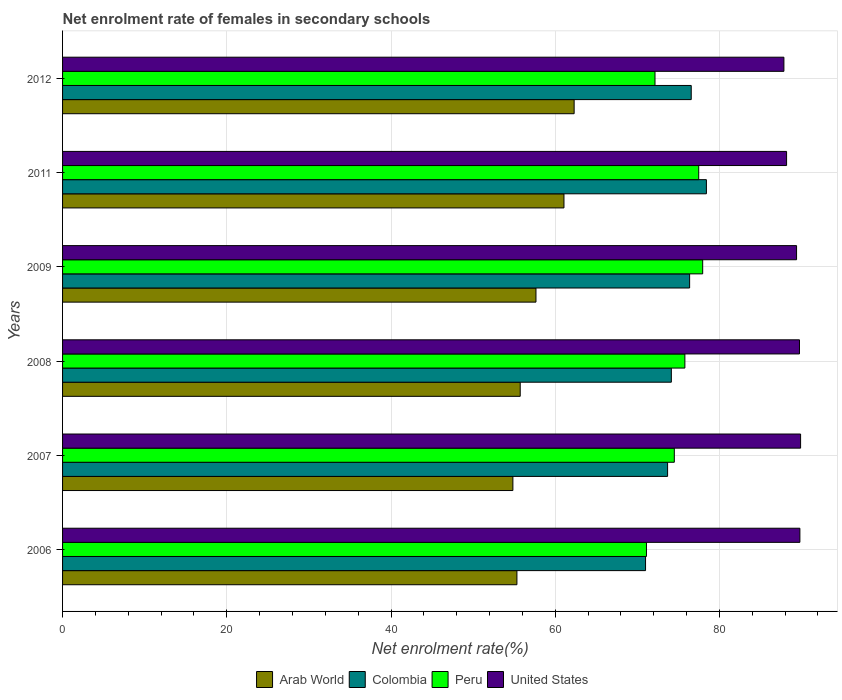How many different coloured bars are there?
Your answer should be very brief. 4. How many bars are there on the 5th tick from the bottom?
Make the answer very short. 4. What is the net enrolment rate of females in secondary schools in United States in 2007?
Make the answer very short. 89.88. Across all years, what is the maximum net enrolment rate of females in secondary schools in Arab World?
Ensure brevity in your answer.  62.3. Across all years, what is the minimum net enrolment rate of females in secondary schools in United States?
Offer a terse response. 87.85. In which year was the net enrolment rate of females in secondary schools in Peru maximum?
Ensure brevity in your answer.  2009. What is the total net enrolment rate of females in secondary schools in Arab World in the graph?
Your answer should be very brief. 346.93. What is the difference between the net enrolment rate of females in secondary schools in Peru in 2007 and that in 2009?
Provide a succinct answer. -3.45. What is the difference between the net enrolment rate of females in secondary schools in Colombia in 2009 and the net enrolment rate of females in secondary schools in Peru in 2011?
Offer a terse response. -1.11. What is the average net enrolment rate of females in secondary schools in Arab World per year?
Ensure brevity in your answer.  57.82. In the year 2008, what is the difference between the net enrolment rate of females in secondary schools in Peru and net enrolment rate of females in secondary schools in Colombia?
Keep it short and to the point. 1.65. What is the ratio of the net enrolment rate of females in secondary schools in United States in 2006 to that in 2008?
Your answer should be compact. 1. Is the difference between the net enrolment rate of females in secondary schools in Peru in 2009 and 2012 greater than the difference between the net enrolment rate of females in secondary schools in Colombia in 2009 and 2012?
Offer a very short reply. Yes. What is the difference between the highest and the second highest net enrolment rate of females in secondary schools in United States?
Provide a succinct answer. 0.08. What is the difference between the highest and the lowest net enrolment rate of females in secondary schools in Peru?
Provide a short and direct response. 6.85. In how many years, is the net enrolment rate of females in secondary schools in Colombia greater than the average net enrolment rate of females in secondary schools in Colombia taken over all years?
Offer a very short reply. 3. Is it the case that in every year, the sum of the net enrolment rate of females in secondary schools in Arab World and net enrolment rate of females in secondary schools in United States is greater than the sum of net enrolment rate of females in secondary schools in Colombia and net enrolment rate of females in secondary schools in Peru?
Provide a succinct answer. No. What does the 1st bar from the bottom in 2009 represents?
Your response must be concise. Arab World. Does the graph contain any zero values?
Offer a terse response. No. How many legend labels are there?
Your response must be concise. 4. What is the title of the graph?
Make the answer very short. Net enrolment rate of females in secondary schools. Does "Benin" appear as one of the legend labels in the graph?
Your response must be concise. No. What is the label or title of the X-axis?
Your response must be concise. Net enrolment rate(%). What is the label or title of the Y-axis?
Your answer should be very brief. Years. What is the Net enrolment rate(%) of Arab World in 2006?
Provide a succinct answer. 55.33. What is the Net enrolment rate(%) of Colombia in 2006?
Keep it short and to the point. 71. What is the Net enrolment rate(%) in Peru in 2006?
Provide a succinct answer. 71.11. What is the Net enrolment rate(%) in United States in 2006?
Ensure brevity in your answer.  89.8. What is the Net enrolment rate(%) of Arab World in 2007?
Keep it short and to the point. 54.84. What is the Net enrolment rate(%) in Colombia in 2007?
Your answer should be very brief. 73.68. What is the Net enrolment rate(%) in Peru in 2007?
Your answer should be compact. 74.5. What is the Net enrolment rate(%) in United States in 2007?
Offer a very short reply. 89.88. What is the Net enrolment rate(%) of Arab World in 2008?
Your answer should be very brief. 55.74. What is the Net enrolment rate(%) in Colombia in 2008?
Keep it short and to the point. 74.14. What is the Net enrolment rate(%) of Peru in 2008?
Your answer should be very brief. 75.79. What is the Net enrolment rate(%) in United States in 2008?
Give a very brief answer. 89.75. What is the Net enrolment rate(%) of Arab World in 2009?
Keep it short and to the point. 57.65. What is the Net enrolment rate(%) in Colombia in 2009?
Provide a short and direct response. 76.37. What is the Net enrolment rate(%) of Peru in 2009?
Your response must be concise. 77.96. What is the Net enrolment rate(%) of United States in 2009?
Give a very brief answer. 89.39. What is the Net enrolment rate(%) of Arab World in 2011?
Offer a terse response. 61.06. What is the Net enrolment rate(%) in Colombia in 2011?
Keep it short and to the point. 78.41. What is the Net enrolment rate(%) in Peru in 2011?
Provide a short and direct response. 77.47. What is the Net enrolment rate(%) of United States in 2011?
Offer a terse response. 88.17. What is the Net enrolment rate(%) in Arab World in 2012?
Provide a succinct answer. 62.3. What is the Net enrolment rate(%) in Colombia in 2012?
Provide a short and direct response. 76.56. What is the Net enrolment rate(%) of Peru in 2012?
Give a very brief answer. 72.15. What is the Net enrolment rate(%) of United States in 2012?
Offer a terse response. 87.85. Across all years, what is the maximum Net enrolment rate(%) of Arab World?
Keep it short and to the point. 62.3. Across all years, what is the maximum Net enrolment rate(%) in Colombia?
Provide a short and direct response. 78.41. Across all years, what is the maximum Net enrolment rate(%) of Peru?
Keep it short and to the point. 77.96. Across all years, what is the maximum Net enrolment rate(%) of United States?
Make the answer very short. 89.88. Across all years, what is the minimum Net enrolment rate(%) of Arab World?
Make the answer very short. 54.84. Across all years, what is the minimum Net enrolment rate(%) in Colombia?
Make the answer very short. 71. Across all years, what is the minimum Net enrolment rate(%) in Peru?
Ensure brevity in your answer.  71.11. Across all years, what is the minimum Net enrolment rate(%) in United States?
Keep it short and to the point. 87.85. What is the total Net enrolment rate(%) of Arab World in the graph?
Offer a terse response. 346.93. What is the total Net enrolment rate(%) of Colombia in the graph?
Ensure brevity in your answer.  450.16. What is the total Net enrolment rate(%) of Peru in the graph?
Give a very brief answer. 448.99. What is the total Net enrolment rate(%) in United States in the graph?
Offer a terse response. 534.84. What is the difference between the Net enrolment rate(%) of Arab World in 2006 and that in 2007?
Your answer should be very brief. 0.49. What is the difference between the Net enrolment rate(%) of Colombia in 2006 and that in 2007?
Offer a terse response. -2.68. What is the difference between the Net enrolment rate(%) of Peru in 2006 and that in 2007?
Offer a terse response. -3.39. What is the difference between the Net enrolment rate(%) of United States in 2006 and that in 2007?
Your answer should be compact. -0.08. What is the difference between the Net enrolment rate(%) of Arab World in 2006 and that in 2008?
Your answer should be compact. -0.4. What is the difference between the Net enrolment rate(%) of Colombia in 2006 and that in 2008?
Offer a very short reply. -3.14. What is the difference between the Net enrolment rate(%) in Peru in 2006 and that in 2008?
Your answer should be very brief. -4.68. What is the difference between the Net enrolment rate(%) in United States in 2006 and that in 2008?
Make the answer very short. 0.05. What is the difference between the Net enrolment rate(%) of Arab World in 2006 and that in 2009?
Your response must be concise. -2.32. What is the difference between the Net enrolment rate(%) in Colombia in 2006 and that in 2009?
Your response must be concise. -5.37. What is the difference between the Net enrolment rate(%) in Peru in 2006 and that in 2009?
Your answer should be very brief. -6.85. What is the difference between the Net enrolment rate(%) of United States in 2006 and that in 2009?
Keep it short and to the point. 0.41. What is the difference between the Net enrolment rate(%) of Arab World in 2006 and that in 2011?
Your answer should be very brief. -5.73. What is the difference between the Net enrolment rate(%) of Colombia in 2006 and that in 2011?
Ensure brevity in your answer.  -7.41. What is the difference between the Net enrolment rate(%) of Peru in 2006 and that in 2011?
Offer a very short reply. -6.36. What is the difference between the Net enrolment rate(%) of United States in 2006 and that in 2011?
Your answer should be compact. 1.62. What is the difference between the Net enrolment rate(%) of Arab World in 2006 and that in 2012?
Offer a very short reply. -6.97. What is the difference between the Net enrolment rate(%) in Colombia in 2006 and that in 2012?
Keep it short and to the point. -5.56. What is the difference between the Net enrolment rate(%) of Peru in 2006 and that in 2012?
Give a very brief answer. -1.04. What is the difference between the Net enrolment rate(%) in United States in 2006 and that in 2012?
Your response must be concise. 1.95. What is the difference between the Net enrolment rate(%) in Arab World in 2007 and that in 2008?
Ensure brevity in your answer.  -0.89. What is the difference between the Net enrolment rate(%) in Colombia in 2007 and that in 2008?
Your answer should be very brief. -0.46. What is the difference between the Net enrolment rate(%) in Peru in 2007 and that in 2008?
Your answer should be very brief. -1.29. What is the difference between the Net enrolment rate(%) of United States in 2007 and that in 2008?
Keep it short and to the point. 0.13. What is the difference between the Net enrolment rate(%) in Arab World in 2007 and that in 2009?
Offer a very short reply. -2.81. What is the difference between the Net enrolment rate(%) in Colombia in 2007 and that in 2009?
Ensure brevity in your answer.  -2.68. What is the difference between the Net enrolment rate(%) in Peru in 2007 and that in 2009?
Offer a terse response. -3.45. What is the difference between the Net enrolment rate(%) of United States in 2007 and that in 2009?
Make the answer very short. 0.49. What is the difference between the Net enrolment rate(%) in Arab World in 2007 and that in 2011?
Make the answer very short. -6.22. What is the difference between the Net enrolment rate(%) of Colombia in 2007 and that in 2011?
Your answer should be compact. -4.73. What is the difference between the Net enrolment rate(%) of Peru in 2007 and that in 2011?
Offer a very short reply. -2.97. What is the difference between the Net enrolment rate(%) of United States in 2007 and that in 2011?
Your answer should be compact. 1.71. What is the difference between the Net enrolment rate(%) in Arab World in 2007 and that in 2012?
Make the answer very short. -7.46. What is the difference between the Net enrolment rate(%) in Colombia in 2007 and that in 2012?
Offer a very short reply. -2.88. What is the difference between the Net enrolment rate(%) of Peru in 2007 and that in 2012?
Your answer should be very brief. 2.35. What is the difference between the Net enrolment rate(%) in United States in 2007 and that in 2012?
Your answer should be compact. 2.03. What is the difference between the Net enrolment rate(%) of Arab World in 2008 and that in 2009?
Give a very brief answer. -1.92. What is the difference between the Net enrolment rate(%) in Colombia in 2008 and that in 2009?
Provide a succinct answer. -2.23. What is the difference between the Net enrolment rate(%) of Peru in 2008 and that in 2009?
Provide a succinct answer. -2.17. What is the difference between the Net enrolment rate(%) in United States in 2008 and that in 2009?
Provide a succinct answer. 0.36. What is the difference between the Net enrolment rate(%) of Arab World in 2008 and that in 2011?
Provide a succinct answer. -5.33. What is the difference between the Net enrolment rate(%) in Colombia in 2008 and that in 2011?
Provide a succinct answer. -4.27. What is the difference between the Net enrolment rate(%) in Peru in 2008 and that in 2011?
Your answer should be very brief. -1.69. What is the difference between the Net enrolment rate(%) in United States in 2008 and that in 2011?
Offer a terse response. 1.57. What is the difference between the Net enrolment rate(%) in Arab World in 2008 and that in 2012?
Your answer should be very brief. -6.57. What is the difference between the Net enrolment rate(%) of Colombia in 2008 and that in 2012?
Your answer should be very brief. -2.42. What is the difference between the Net enrolment rate(%) of Peru in 2008 and that in 2012?
Your answer should be compact. 3.64. What is the difference between the Net enrolment rate(%) of United States in 2008 and that in 2012?
Ensure brevity in your answer.  1.9. What is the difference between the Net enrolment rate(%) of Arab World in 2009 and that in 2011?
Provide a succinct answer. -3.41. What is the difference between the Net enrolment rate(%) in Colombia in 2009 and that in 2011?
Offer a very short reply. -2.04. What is the difference between the Net enrolment rate(%) in Peru in 2009 and that in 2011?
Provide a short and direct response. 0.48. What is the difference between the Net enrolment rate(%) in United States in 2009 and that in 2011?
Provide a succinct answer. 1.22. What is the difference between the Net enrolment rate(%) in Arab World in 2009 and that in 2012?
Offer a very short reply. -4.65. What is the difference between the Net enrolment rate(%) of Colombia in 2009 and that in 2012?
Ensure brevity in your answer.  -0.19. What is the difference between the Net enrolment rate(%) of Peru in 2009 and that in 2012?
Make the answer very short. 5.81. What is the difference between the Net enrolment rate(%) in United States in 2009 and that in 2012?
Offer a terse response. 1.54. What is the difference between the Net enrolment rate(%) of Arab World in 2011 and that in 2012?
Provide a succinct answer. -1.24. What is the difference between the Net enrolment rate(%) in Colombia in 2011 and that in 2012?
Ensure brevity in your answer.  1.85. What is the difference between the Net enrolment rate(%) of Peru in 2011 and that in 2012?
Keep it short and to the point. 5.32. What is the difference between the Net enrolment rate(%) in United States in 2011 and that in 2012?
Offer a terse response. 0.33. What is the difference between the Net enrolment rate(%) of Arab World in 2006 and the Net enrolment rate(%) of Colombia in 2007?
Keep it short and to the point. -18.35. What is the difference between the Net enrolment rate(%) in Arab World in 2006 and the Net enrolment rate(%) in Peru in 2007?
Offer a very short reply. -19.17. What is the difference between the Net enrolment rate(%) of Arab World in 2006 and the Net enrolment rate(%) of United States in 2007?
Your response must be concise. -34.55. What is the difference between the Net enrolment rate(%) of Colombia in 2006 and the Net enrolment rate(%) of Peru in 2007?
Offer a very short reply. -3.5. What is the difference between the Net enrolment rate(%) in Colombia in 2006 and the Net enrolment rate(%) in United States in 2007?
Make the answer very short. -18.88. What is the difference between the Net enrolment rate(%) of Peru in 2006 and the Net enrolment rate(%) of United States in 2007?
Make the answer very short. -18.77. What is the difference between the Net enrolment rate(%) of Arab World in 2006 and the Net enrolment rate(%) of Colombia in 2008?
Make the answer very short. -18.81. What is the difference between the Net enrolment rate(%) of Arab World in 2006 and the Net enrolment rate(%) of Peru in 2008?
Your response must be concise. -20.45. What is the difference between the Net enrolment rate(%) in Arab World in 2006 and the Net enrolment rate(%) in United States in 2008?
Make the answer very short. -34.41. What is the difference between the Net enrolment rate(%) of Colombia in 2006 and the Net enrolment rate(%) of Peru in 2008?
Offer a very short reply. -4.79. What is the difference between the Net enrolment rate(%) in Colombia in 2006 and the Net enrolment rate(%) in United States in 2008?
Keep it short and to the point. -18.75. What is the difference between the Net enrolment rate(%) in Peru in 2006 and the Net enrolment rate(%) in United States in 2008?
Make the answer very short. -18.64. What is the difference between the Net enrolment rate(%) in Arab World in 2006 and the Net enrolment rate(%) in Colombia in 2009?
Offer a terse response. -21.03. What is the difference between the Net enrolment rate(%) in Arab World in 2006 and the Net enrolment rate(%) in Peru in 2009?
Your response must be concise. -22.62. What is the difference between the Net enrolment rate(%) in Arab World in 2006 and the Net enrolment rate(%) in United States in 2009?
Offer a very short reply. -34.06. What is the difference between the Net enrolment rate(%) in Colombia in 2006 and the Net enrolment rate(%) in Peru in 2009?
Provide a short and direct response. -6.96. What is the difference between the Net enrolment rate(%) in Colombia in 2006 and the Net enrolment rate(%) in United States in 2009?
Ensure brevity in your answer.  -18.39. What is the difference between the Net enrolment rate(%) in Peru in 2006 and the Net enrolment rate(%) in United States in 2009?
Ensure brevity in your answer.  -18.28. What is the difference between the Net enrolment rate(%) in Arab World in 2006 and the Net enrolment rate(%) in Colombia in 2011?
Provide a short and direct response. -23.08. What is the difference between the Net enrolment rate(%) of Arab World in 2006 and the Net enrolment rate(%) of Peru in 2011?
Ensure brevity in your answer.  -22.14. What is the difference between the Net enrolment rate(%) of Arab World in 2006 and the Net enrolment rate(%) of United States in 2011?
Offer a very short reply. -32.84. What is the difference between the Net enrolment rate(%) in Colombia in 2006 and the Net enrolment rate(%) in Peru in 2011?
Provide a succinct answer. -6.48. What is the difference between the Net enrolment rate(%) of Colombia in 2006 and the Net enrolment rate(%) of United States in 2011?
Provide a succinct answer. -17.18. What is the difference between the Net enrolment rate(%) of Peru in 2006 and the Net enrolment rate(%) of United States in 2011?
Keep it short and to the point. -17.06. What is the difference between the Net enrolment rate(%) in Arab World in 2006 and the Net enrolment rate(%) in Colombia in 2012?
Provide a short and direct response. -21.23. What is the difference between the Net enrolment rate(%) in Arab World in 2006 and the Net enrolment rate(%) in Peru in 2012?
Your answer should be very brief. -16.82. What is the difference between the Net enrolment rate(%) in Arab World in 2006 and the Net enrolment rate(%) in United States in 2012?
Ensure brevity in your answer.  -32.52. What is the difference between the Net enrolment rate(%) of Colombia in 2006 and the Net enrolment rate(%) of Peru in 2012?
Your answer should be compact. -1.15. What is the difference between the Net enrolment rate(%) in Colombia in 2006 and the Net enrolment rate(%) in United States in 2012?
Keep it short and to the point. -16.85. What is the difference between the Net enrolment rate(%) in Peru in 2006 and the Net enrolment rate(%) in United States in 2012?
Provide a succinct answer. -16.74. What is the difference between the Net enrolment rate(%) of Arab World in 2007 and the Net enrolment rate(%) of Colombia in 2008?
Give a very brief answer. -19.3. What is the difference between the Net enrolment rate(%) in Arab World in 2007 and the Net enrolment rate(%) in Peru in 2008?
Provide a succinct answer. -20.94. What is the difference between the Net enrolment rate(%) in Arab World in 2007 and the Net enrolment rate(%) in United States in 2008?
Your answer should be very brief. -34.9. What is the difference between the Net enrolment rate(%) in Colombia in 2007 and the Net enrolment rate(%) in Peru in 2008?
Your answer should be very brief. -2.11. What is the difference between the Net enrolment rate(%) of Colombia in 2007 and the Net enrolment rate(%) of United States in 2008?
Offer a terse response. -16.06. What is the difference between the Net enrolment rate(%) in Peru in 2007 and the Net enrolment rate(%) in United States in 2008?
Provide a short and direct response. -15.24. What is the difference between the Net enrolment rate(%) in Arab World in 2007 and the Net enrolment rate(%) in Colombia in 2009?
Provide a short and direct response. -21.52. What is the difference between the Net enrolment rate(%) of Arab World in 2007 and the Net enrolment rate(%) of Peru in 2009?
Ensure brevity in your answer.  -23.11. What is the difference between the Net enrolment rate(%) in Arab World in 2007 and the Net enrolment rate(%) in United States in 2009?
Your response must be concise. -34.55. What is the difference between the Net enrolment rate(%) of Colombia in 2007 and the Net enrolment rate(%) of Peru in 2009?
Your response must be concise. -4.27. What is the difference between the Net enrolment rate(%) of Colombia in 2007 and the Net enrolment rate(%) of United States in 2009?
Your response must be concise. -15.71. What is the difference between the Net enrolment rate(%) in Peru in 2007 and the Net enrolment rate(%) in United States in 2009?
Make the answer very short. -14.89. What is the difference between the Net enrolment rate(%) of Arab World in 2007 and the Net enrolment rate(%) of Colombia in 2011?
Give a very brief answer. -23.57. What is the difference between the Net enrolment rate(%) in Arab World in 2007 and the Net enrolment rate(%) in Peru in 2011?
Offer a terse response. -22.63. What is the difference between the Net enrolment rate(%) in Arab World in 2007 and the Net enrolment rate(%) in United States in 2011?
Ensure brevity in your answer.  -33.33. What is the difference between the Net enrolment rate(%) of Colombia in 2007 and the Net enrolment rate(%) of Peru in 2011?
Offer a terse response. -3.79. What is the difference between the Net enrolment rate(%) of Colombia in 2007 and the Net enrolment rate(%) of United States in 2011?
Offer a terse response. -14.49. What is the difference between the Net enrolment rate(%) in Peru in 2007 and the Net enrolment rate(%) in United States in 2011?
Offer a terse response. -13.67. What is the difference between the Net enrolment rate(%) in Arab World in 2007 and the Net enrolment rate(%) in Colombia in 2012?
Provide a succinct answer. -21.72. What is the difference between the Net enrolment rate(%) of Arab World in 2007 and the Net enrolment rate(%) of Peru in 2012?
Ensure brevity in your answer.  -17.31. What is the difference between the Net enrolment rate(%) in Arab World in 2007 and the Net enrolment rate(%) in United States in 2012?
Your answer should be very brief. -33. What is the difference between the Net enrolment rate(%) in Colombia in 2007 and the Net enrolment rate(%) in Peru in 2012?
Provide a succinct answer. 1.53. What is the difference between the Net enrolment rate(%) of Colombia in 2007 and the Net enrolment rate(%) of United States in 2012?
Your answer should be very brief. -14.17. What is the difference between the Net enrolment rate(%) in Peru in 2007 and the Net enrolment rate(%) in United States in 2012?
Your response must be concise. -13.35. What is the difference between the Net enrolment rate(%) in Arab World in 2008 and the Net enrolment rate(%) in Colombia in 2009?
Your response must be concise. -20.63. What is the difference between the Net enrolment rate(%) of Arab World in 2008 and the Net enrolment rate(%) of Peru in 2009?
Keep it short and to the point. -22.22. What is the difference between the Net enrolment rate(%) in Arab World in 2008 and the Net enrolment rate(%) in United States in 2009?
Your answer should be compact. -33.66. What is the difference between the Net enrolment rate(%) in Colombia in 2008 and the Net enrolment rate(%) in Peru in 2009?
Give a very brief answer. -3.82. What is the difference between the Net enrolment rate(%) of Colombia in 2008 and the Net enrolment rate(%) of United States in 2009?
Ensure brevity in your answer.  -15.25. What is the difference between the Net enrolment rate(%) in Peru in 2008 and the Net enrolment rate(%) in United States in 2009?
Make the answer very short. -13.6. What is the difference between the Net enrolment rate(%) in Arab World in 2008 and the Net enrolment rate(%) in Colombia in 2011?
Make the answer very short. -22.67. What is the difference between the Net enrolment rate(%) of Arab World in 2008 and the Net enrolment rate(%) of Peru in 2011?
Your answer should be very brief. -21.74. What is the difference between the Net enrolment rate(%) of Arab World in 2008 and the Net enrolment rate(%) of United States in 2011?
Offer a terse response. -32.44. What is the difference between the Net enrolment rate(%) of Colombia in 2008 and the Net enrolment rate(%) of Peru in 2011?
Your answer should be compact. -3.33. What is the difference between the Net enrolment rate(%) in Colombia in 2008 and the Net enrolment rate(%) in United States in 2011?
Provide a short and direct response. -14.03. What is the difference between the Net enrolment rate(%) of Peru in 2008 and the Net enrolment rate(%) of United States in 2011?
Make the answer very short. -12.39. What is the difference between the Net enrolment rate(%) in Arab World in 2008 and the Net enrolment rate(%) in Colombia in 2012?
Make the answer very short. -20.83. What is the difference between the Net enrolment rate(%) of Arab World in 2008 and the Net enrolment rate(%) of Peru in 2012?
Your answer should be compact. -16.41. What is the difference between the Net enrolment rate(%) in Arab World in 2008 and the Net enrolment rate(%) in United States in 2012?
Keep it short and to the point. -32.11. What is the difference between the Net enrolment rate(%) of Colombia in 2008 and the Net enrolment rate(%) of Peru in 2012?
Keep it short and to the point. 1.99. What is the difference between the Net enrolment rate(%) of Colombia in 2008 and the Net enrolment rate(%) of United States in 2012?
Your answer should be very brief. -13.71. What is the difference between the Net enrolment rate(%) in Peru in 2008 and the Net enrolment rate(%) in United States in 2012?
Your answer should be very brief. -12.06. What is the difference between the Net enrolment rate(%) of Arab World in 2009 and the Net enrolment rate(%) of Colombia in 2011?
Your response must be concise. -20.76. What is the difference between the Net enrolment rate(%) in Arab World in 2009 and the Net enrolment rate(%) in Peru in 2011?
Your response must be concise. -19.82. What is the difference between the Net enrolment rate(%) of Arab World in 2009 and the Net enrolment rate(%) of United States in 2011?
Make the answer very short. -30.52. What is the difference between the Net enrolment rate(%) of Colombia in 2009 and the Net enrolment rate(%) of Peru in 2011?
Your answer should be very brief. -1.11. What is the difference between the Net enrolment rate(%) in Colombia in 2009 and the Net enrolment rate(%) in United States in 2011?
Provide a short and direct response. -11.81. What is the difference between the Net enrolment rate(%) of Peru in 2009 and the Net enrolment rate(%) of United States in 2011?
Give a very brief answer. -10.22. What is the difference between the Net enrolment rate(%) in Arab World in 2009 and the Net enrolment rate(%) in Colombia in 2012?
Provide a short and direct response. -18.91. What is the difference between the Net enrolment rate(%) in Arab World in 2009 and the Net enrolment rate(%) in Peru in 2012?
Offer a very short reply. -14.5. What is the difference between the Net enrolment rate(%) in Arab World in 2009 and the Net enrolment rate(%) in United States in 2012?
Ensure brevity in your answer.  -30.19. What is the difference between the Net enrolment rate(%) of Colombia in 2009 and the Net enrolment rate(%) of Peru in 2012?
Ensure brevity in your answer.  4.22. What is the difference between the Net enrolment rate(%) in Colombia in 2009 and the Net enrolment rate(%) in United States in 2012?
Your answer should be compact. -11.48. What is the difference between the Net enrolment rate(%) of Peru in 2009 and the Net enrolment rate(%) of United States in 2012?
Give a very brief answer. -9.89. What is the difference between the Net enrolment rate(%) of Arab World in 2011 and the Net enrolment rate(%) of Colombia in 2012?
Offer a very short reply. -15.5. What is the difference between the Net enrolment rate(%) of Arab World in 2011 and the Net enrolment rate(%) of Peru in 2012?
Your response must be concise. -11.09. What is the difference between the Net enrolment rate(%) in Arab World in 2011 and the Net enrolment rate(%) in United States in 2012?
Your response must be concise. -26.78. What is the difference between the Net enrolment rate(%) in Colombia in 2011 and the Net enrolment rate(%) in Peru in 2012?
Keep it short and to the point. 6.26. What is the difference between the Net enrolment rate(%) of Colombia in 2011 and the Net enrolment rate(%) of United States in 2012?
Offer a terse response. -9.44. What is the difference between the Net enrolment rate(%) of Peru in 2011 and the Net enrolment rate(%) of United States in 2012?
Your response must be concise. -10.37. What is the average Net enrolment rate(%) of Arab World per year?
Give a very brief answer. 57.82. What is the average Net enrolment rate(%) in Colombia per year?
Your response must be concise. 75.03. What is the average Net enrolment rate(%) of Peru per year?
Offer a very short reply. 74.83. What is the average Net enrolment rate(%) of United States per year?
Your response must be concise. 89.14. In the year 2006, what is the difference between the Net enrolment rate(%) of Arab World and Net enrolment rate(%) of Colombia?
Your answer should be compact. -15.67. In the year 2006, what is the difference between the Net enrolment rate(%) of Arab World and Net enrolment rate(%) of Peru?
Your answer should be very brief. -15.78. In the year 2006, what is the difference between the Net enrolment rate(%) of Arab World and Net enrolment rate(%) of United States?
Give a very brief answer. -34.46. In the year 2006, what is the difference between the Net enrolment rate(%) in Colombia and Net enrolment rate(%) in Peru?
Offer a terse response. -0.11. In the year 2006, what is the difference between the Net enrolment rate(%) of Colombia and Net enrolment rate(%) of United States?
Give a very brief answer. -18.8. In the year 2006, what is the difference between the Net enrolment rate(%) in Peru and Net enrolment rate(%) in United States?
Ensure brevity in your answer.  -18.68. In the year 2007, what is the difference between the Net enrolment rate(%) of Arab World and Net enrolment rate(%) of Colombia?
Keep it short and to the point. -18.84. In the year 2007, what is the difference between the Net enrolment rate(%) of Arab World and Net enrolment rate(%) of Peru?
Provide a succinct answer. -19.66. In the year 2007, what is the difference between the Net enrolment rate(%) of Arab World and Net enrolment rate(%) of United States?
Ensure brevity in your answer.  -35.04. In the year 2007, what is the difference between the Net enrolment rate(%) in Colombia and Net enrolment rate(%) in Peru?
Offer a terse response. -0.82. In the year 2007, what is the difference between the Net enrolment rate(%) of Colombia and Net enrolment rate(%) of United States?
Your answer should be compact. -16.2. In the year 2007, what is the difference between the Net enrolment rate(%) in Peru and Net enrolment rate(%) in United States?
Keep it short and to the point. -15.38. In the year 2008, what is the difference between the Net enrolment rate(%) of Arab World and Net enrolment rate(%) of Colombia?
Give a very brief answer. -18.4. In the year 2008, what is the difference between the Net enrolment rate(%) of Arab World and Net enrolment rate(%) of Peru?
Make the answer very short. -20.05. In the year 2008, what is the difference between the Net enrolment rate(%) in Arab World and Net enrolment rate(%) in United States?
Give a very brief answer. -34.01. In the year 2008, what is the difference between the Net enrolment rate(%) in Colombia and Net enrolment rate(%) in Peru?
Offer a very short reply. -1.65. In the year 2008, what is the difference between the Net enrolment rate(%) in Colombia and Net enrolment rate(%) in United States?
Keep it short and to the point. -15.61. In the year 2008, what is the difference between the Net enrolment rate(%) of Peru and Net enrolment rate(%) of United States?
Your answer should be very brief. -13.96. In the year 2009, what is the difference between the Net enrolment rate(%) of Arab World and Net enrolment rate(%) of Colombia?
Provide a succinct answer. -18.71. In the year 2009, what is the difference between the Net enrolment rate(%) in Arab World and Net enrolment rate(%) in Peru?
Your answer should be very brief. -20.3. In the year 2009, what is the difference between the Net enrolment rate(%) of Arab World and Net enrolment rate(%) of United States?
Give a very brief answer. -31.74. In the year 2009, what is the difference between the Net enrolment rate(%) of Colombia and Net enrolment rate(%) of Peru?
Offer a terse response. -1.59. In the year 2009, what is the difference between the Net enrolment rate(%) in Colombia and Net enrolment rate(%) in United States?
Give a very brief answer. -13.02. In the year 2009, what is the difference between the Net enrolment rate(%) of Peru and Net enrolment rate(%) of United States?
Your answer should be very brief. -11.43. In the year 2011, what is the difference between the Net enrolment rate(%) in Arab World and Net enrolment rate(%) in Colombia?
Your answer should be compact. -17.35. In the year 2011, what is the difference between the Net enrolment rate(%) in Arab World and Net enrolment rate(%) in Peru?
Your answer should be compact. -16.41. In the year 2011, what is the difference between the Net enrolment rate(%) in Arab World and Net enrolment rate(%) in United States?
Offer a very short reply. -27.11. In the year 2011, what is the difference between the Net enrolment rate(%) in Colombia and Net enrolment rate(%) in Peru?
Give a very brief answer. 0.94. In the year 2011, what is the difference between the Net enrolment rate(%) of Colombia and Net enrolment rate(%) of United States?
Ensure brevity in your answer.  -9.76. In the year 2011, what is the difference between the Net enrolment rate(%) in Peru and Net enrolment rate(%) in United States?
Make the answer very short. -10.7. In the year 2012, what is the difference between the Net enrolment rate(%) of Arab World and Net enrolment rate(%) of Colombia?
Provide a succinct answer. -14.26. In the year 2012, what is the difference between the Net enrolment rate(%) of Arab World and Net enrolment rate(%) of Peru?
Provide a succinct answer. -9.85. In the year 2012, what is the difference between the Net enrolment rate(%) of Arab World and Net enrolment rate(%) of United States?
Offer a terse response. -25.55. In the year 2012, what is the difference between the Net enrolment rate(%) of Colombia and Net enrolment rate(%) of Peru?
Your answer should be very brief. 4.41. In the year 2012, what is the difference between the Net enrolment rate(%) of Colombia and Net enrolment rate(%) of United States?
Your response must be concise. -11.29. In the year 2012, what is the difference between the Net enrolment rate(%) in Peru and Net enrolment rate(%) in United States?
Your answer should be very brief. -15.7. What is the ratio of the Net enrolment rate(%) of Arab World in 2006 to that in 2007?
Keep it short and to the point. 1.01. What is the ratio of the Net enrolment rate(%) of Colombia in 2006 to that in 2007?
Make the answer very short. 0.96. What is the ratio of the Net enrolment rate(%) in Peru in 2006 to that in 2007?
Provide a short and direct response. 0.95. What is the ratio of the Net enrolment rate(%) of United States in 2006 to that in 2007?
Make the answer very short. 1. What is the ratio of the Net enrolment rate(%) of Arab World in 2006 to that in 2008?
Keep it short and to the point. 0.99. What is the ratio of the Net enrolment rate(%) of Colombia in 2006 to that in 2008?
Give a very brief answer. 0.96. What is the ratio of the Net enrolment rate(%) in Peru in 2006 to that in 2008?
Offer a terse response. 0.94. What is the ratio of the Net enrolment rate(%) in Arab World in 2006 to that in 2009?
Keep it short and to the point. 0.96. What is the ratio of the Net enrolment rate(%) of Colombia in 2006 to that in 2009?
Provide a short and direct response. 0.93. What is the ratio of the Net enrolment rate(%) in Peru in 2006 to that in 2009?
Offer a terse response. 0.91. What is the ratio of the Net enrolment rate(%) of United States in 2006 to that in 2009?
Your response must be concise. 1. What is the ratio of the Net enrolment rate(%) of Arab World in 2006 to that in 2011?
Give a very brief answer. 0.91. What is the ratio of the Net enrolment rate(%) in Colombia in 2006 to that in 2011?
Make the answer very short. 0.91. What is the ratio of the Net enrolment rate(%) of Peru in 2006 to that in 2011?
Make the answer very short. 0.92. What is the ratio of the Net enrolment rate(%) in United States in 2006 to that in 2011?
Your response must be concise. 1.02. What is the ratio of the Net enrolment rate(%) of Arab World in 2006 to that in 2012?
Ensure brevity in your answer.  0.89. What is the ratio of the Net enrolment rate(%) of Colombia in 2006 to that in 2012?
Your answer should be compact. 0.93. What is the ratio of the Net enrolment rate(%) in Peru in 2006 to that in 2012?
Your answer should be compact. 0.99. What is the ratio of the Net enrolment rate(%) in United States in 2006 to that in 2012?
Offer a very short reply. 1.02. What is the ratio of the Net enrolment rate(%) of Colombia in 2007 to that in 2008?
Your answer should be very brief. 0.99. What is the ratio of the Net enrolment rate(%) of United States in 2007 to that in 2008?
Your answer should be compact. 1. What is the ratio of the Net enrolment rate(%) of Arab World in 2007 to that in 2009?
Provide a short and direct response. 0.95. What is the ratio of the Net enrolment rate(%) of Colombia in 2007 to that in 2009?
Your response must be concise. 0.96. What is the ratio of the Net enrolment rate(%) of Peru in 2007 to that in 2009?
Your answer should be very brief. 0.96. What is the ratio of the Net enrolment rate(%) in Arab World in 2007 to that in 2011?
Provide a succinct answer. 0.9. What is the ratio of the Net enrolment rate(%) in Colombia in 2007 to that in 2011?
Ensure brevity in your answer.  0.94. What is the ratio of the Net enrolment rate(%) of Peru in 2007 to that in 2011?
Ensure brevity in your answer.  0.96. What is the ratio of the Net enrolment rate(%) in United States in 2007 to that in 2011?
Keep it short and to the point. 1.02. What is the ratio of the Net enrolment rate(%) in Arab World in 2007 to that in 2012?
Your answer should be compact. 0.88. What is the ratio of the Net enrolment rate(%) of Colombia in 2007 to that in 2012?
Ensure brevity in your answer.  0.96. What is the ratio of the Net enrolment rate(%) in Peru in 2007 to that in 2012?
Your response must be concise. 1.03. What is the ratio of the Net enrolment rate(%) of United States in 2007 to that in 2012?
Offer a terse response. 1.02. What is the ratio of the Net enrolment rate(%) in Arab World in 2008 to that in 2009?
Your answer should be very brief. 0.97. What is the ratio of the Net enrolment rate(%) of Colombia in 2008 to that in 2009?
Make the answer very short. 0.97. What is the ratio of the Net enrolment rate(%) in Peru in 2008 to that in 2009?
Provide a succinct answer. 0.97. What is the ratio of the Net enrolment rate(%) in Arab World in 2008 to that in 2011?
Your response must be concise. 0.91. What is the ratio of the Net enrolment rate(%) in Colombia in 2008 to that in 2011?
Offer a terse response. 0.95. What is the ratio of the Net enrolment rate(%) in Peru in 2008 to that in 2011?
Keep it short and to the point. 0.98. What is the ratio of the Net enrolment rate(%) of United States in 2008 to that in 2011?
Your response must be concise. 1.02. What is the ratio of the Net enrolment rate(%) in Arab World in 2008 to that in 2012?
Your response must be concise. 0.89. What is the ratio of the Net enrolment rate(%) of Colombia in 2008 to that in 2012?
Your response must be concise. 0.97. What is the ratio of the Net enrolment rate(%) in Peru in 2008 to that in 2012?
Give a very brief answer. 1.05. What is the ratio of the Net enrolment rate(%) of United States in 2008 to that in 2012?
Provide a succinct answer. 1.02. What is the ratio of the Net enrolment rate(%) in Arab World in 2009 to that in 2011?
Ensure brevity in your answer.  0.94. What is the ratio of the Net enrolment rate(%) in Peru in 2009 to that in 2011?
Make the answer very short. 1.01. What is the ratio of the Net enrolment rate(%) of United States in 2009 to that in 2011?
Ensure brevity in your answer.  1.01. What is the ratio of the Net enrolment rate(%) in Arab World in 2009 to that in 2012?
Your answer should be very brief. 0.93. What is the ratio of the Net enrolment rate(%) of Colombia in 2009 to that in 2012?
Give a very brief answer. 1. What is the ratio of the Net enrolment rate(%) of Peru in 2009 to that in 2012?
Give a very brief answer. 1.08. What is the ratio of the Net enrolment rate(%) in United States in 2009 to that in 2012?
Offer a very short reply. 1.02. What is the ratio of the Net enrolment rate(%) of Arab World in 2011 to that in 2012?
Make the answer very short. 0.98. What is the ratio of the Net enrolment rate(%) of Colombia in 2011 to that in 2012?
Your answer should be compact. 1.02. What is the ratio of the Net enrolment rate(%) in Peru in 2011 to that in 2012?
Offer a very short reply. 1.07. What is the difference between the highest and the second highest Net enrolment rate(%) of Arab World?
Your answer should be compact. 1.24. What is the difference between the highest and the second highest Net enrolment rate(%) in Colombia?
Your response must be concise. 1.85. What is the difference between the highest and the second highest Net enrolment rate(%) in Peru?
Give a very brief answer. 0.48. What is the difference between the highest and the second highest Net enrolment rate(%) in United States?
Make the answer very short. 0.08. What is the difference between the highest and the lowest Net enrolment rate(%) of Arab World?
Offer a very short reply. 7.46. What is the difference between the highest and the lowest Net enrolment rate(%) in Colombia?
Provide a short and direct response. 7.41. What is the difference between the highest and the lowest Net enrolment rate(%) of Peru?
Your answer should be compact. 6.85. What is the difference between the highest and the lowest Net enrolment rate(%) of United States?
Provide a succinct answer. 2.03. 